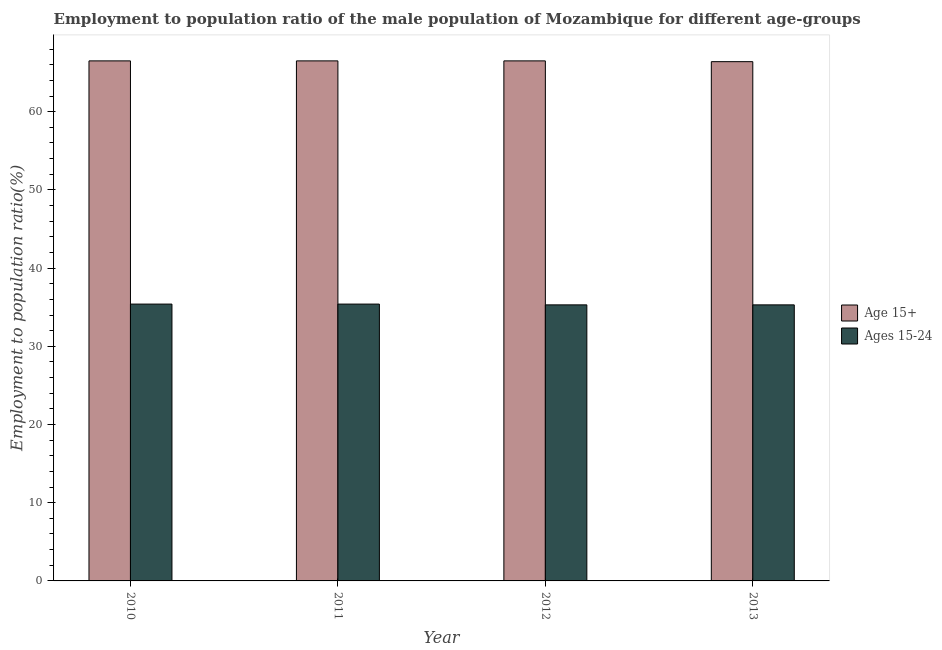How many different coloured bars are there?
Ensure brevity in your answer.  2. How many groups of bars are there?
Give a very brief answer. 4. Are the number of bars on each tick of the X-axis equal?
Give a very brief answer. Yes. How many bars are there on the 1st tick from the left?
Ensure brevity in your answer.  2. How many bars are there on the 1st tick from the right?
Ensure brevity in your answer.  2. What is the label of the 1st group of bars from the left?
Provide a short and direct response. 2010. What is the employment to population ratio(age 15-24) in 2013?
Your response must be concise. 35.3. Across all years, what is the maximum employment to population ratio(age 15+)?
Give a very brief answer. 66.5. Across all years, what is the minimum employment to population ratio(age 15-24)?
Provide a succinct answer. 35.3. In which year was the employment to population ratio(age 15+) maximum?
Offer a terse response. 2010. What is the total employment to population ratio(age 15-24) in the graph?
Provide a short and direct response. 141.4. What is the difference between the employment to population ratio(age 15-24) in 2010 and that in 2011?
Your answer should be very brief. 0. What is the difference between the employment to population ratio(age 15-24) in 2011 and the employment to population ratio(age 15+) in 2013?
Provide a short and direct response. 0.1. What is the average employment to population ratio(age 15+) per year?
Your response must be concise. 66.48. In the year 2013, what is the difference between the employment to population ratio(age 15-24) and employment to population ratio(age 15+)?
Your response must be concise. 0. In how many years, is the employment to population ratio(age 15-24) greater than 42 %?
Give a very brief answer. 0. What is the ratio of the employment to population ratio(age 15+) in 2010 to that in 2013?
Ensure brevity in your answer.  1. What is the difference between the highest and the lowest employment to population ratio(age 15+)?
Your answer should be compact. 0.1. In how many years, is the employment to population ratio(age 15+) greater than the average employment to population ratio(age 15+) taken over all years?
Provide a succinct answer. 3. What does the 1st bar from the left in 2010 represents?
Offer a terse response. Age 15+. What does the 2nd bar from the right in 2013 represents?
Offer a terse response. Age 15+. How many bars are there?
Your answer should be very brief. 8. What is the difference between two consecutive major ticks on the Y-axis?
Ensure brevity in your answer.  10. Are the values on the major ticks of Y-axis written in scientific E-notation?
Make the answer very short. No. How many legend labels are there?
Your response must be concise. 2. What is the title of the graph?
Provide a succinct answer. Employment to population ratio of the male population of Mozambique for different age-groups. What is the label or title of the Y-axis?
Offer a very short reply. Employment to population ratio(%). What is the Employment to population ratio(%) in Age 15+ in 2010?
Provide a short and direct response. 66.5. What is the Employment to population ratio(%) of Ages 15-24 in 2010?
Ensure brevity in your answer.  35.4. What is the Employment to population ratio(%) in Age 15+ in 2011?
Keep it short and to the point. 66.5. What is the Employment to population ratio(%) of Ages 15-24 in 2011?
Keep it short and to the point. 35.4. What is the Employment to population ratio(%) of Age 15+ in 2012?
Keep it short and to the point. 66.5. What is the Employment to population ratio(%) of Ages 15-24 in 2012?
Keep it short and to the point. 35.3. What is the Employment to population ratio(%) of Age 15+ in 2013?
Keep it short and to the point. 66.4. What is the Employment to population ratio(%) of Ages 15-24 in 2013?
Offer a very short reply. 35.3. Across all years, what is the maximum Employment to population ratio(%) of Age 15+?
Give a very brief answer. 66.5. Across all years, what is the maximum Employment to population ratio(%) in Ages 15-24?
Your response must be concise. 35.4. Across all years, what is the minimum Employment to population ratio(%) of Age 15+?
Offer a very short reply. 66.4. Across all years, what is the minimum Employment to population ratio(%) in Ages 15-24?
Make the answer very short. 35.3. What is the total Employment to population ratio(%) of Age 15+ in the graph?
Your answer should be very brief. 265.9. What is the total Employment to population ratio(%) of Ages 15-24 in the graph?
Your response must be concise. 141.4. What is the difference between the Employment to population ratio(%) in Age 15+ in 2010 and that in 2011?
Provide a short and direct response. 0. What is the difference between the Employment to population ratio(%) in Ages 15-24 in 2010 and that in 2011?
Your response must be concise. 0. What is the difference between the Employment to population ratio(%) of Ages 15-24 in 2010 and that in 2012?
Your answer should be compact. 0.1. What is the difference between the Employment to population ratio(%) of Age 15+ in 2012 and that in 2013?
Give a very brief answer. 0.1. What is the difference between the Employment to population ratio(%) in Ages 15-24 in 2012 and that in 2013?
Your answer should be compact. 0. What is the difference between the Employment to population ratio(%) of Age 15+ in 2010 and the Employment to population ratio(%) of Ages 15-24 in 2011?
Make the answer very short. 31.1. What is the difference between the Employment to population ratio(%) of Age 15+ in 2010 and the Employment to population ratio(%) of Ages 15-24 in 2012?
Your answer should be compact. 31.2. What is the difference between the Employment to population ratio(%) of Age 15+ in 2010 and the Employment to population ratio(%) of Ages 15-24 in 2013?
Offer a terse response. 31.2. What is the difference between the Employment to population ratio(%) in Age 15+ in 2011 and the Employment to population ratio(%) in Ages 15-24 in 2012?
Provide a succinct answer. 31.2. What is the difference between the Employment to population ratio(%) in Age 15+ in 2011 and the Employment to population ratio(%) in Ages 15-24 in 2013?
Your response must be concise. 31.2. What is the difference between the Employment to population ratio(%) in Age 15+ in 2012 and the Employment to population ratio(%) in Ages 15-24 in 2013?
Offer a terse response. 31.2. What is the average Employment to population ratio(%) in Age 15+ per year?
Offer a terse response. 66.47. What is the average Employment to population ratio(%) of Ages 15-24 per year?
Your answer should be very brief. 35.35. In the year 2010, what is the difference between the Employment to population ratio(%) of Age 15+ and Employment to population ratio(%) of Ages 15-24?
Offer a terse response. 31.1. In the year 2011, what is the difference between the Employment to population ratio(%) of Age 15+ and Employment to population ratio(%) of Ages 15-24?
Make the answer very short. 31.1. In the year 2012, what is the difference between the Employment to population ratio(%) of Age 15+ and Employment to population ratio(%) of Ages 15-24?
Offer a terse response. 31.2. In the year 2013, what is the difference between the Employment to population ratio(%) in Age 15+ and Employment to population ratio(%) in Ages 15-24?
Provide a short and direct response. 31.1. What is the ratio of the Employment to population ratio(%) of Age 15+ in 2010 to that in 2011?
Offer a terse response. 1. What is the ratio of the Employment to population ratio(%) of Ages 15-24 in 2010 to that in 2011?
Provide a succinct answer. 1. What is the ratio of the Employment to population ratio(%) of Ages 15-24 in 2010 to that in 2012?
Make the answer very short. 1. What is the ratio of the Employment to population ratio(%) in Age 15+ in 2011 to that in 2012?
Your answer should be very brief. 1. What is the ratio of the Employment to population ratio(%) in Ages 15-24 in 2011 to that in 2012?
Offer a very short reply. 1. What is the ratio of the Employment to population ratio(%) in Ages 15-24 in 2011 to that in 2013?
Provide a short and direct response. 1. What is the difference between the highest and the second highest Employment to population ratio(%) of Age 15+?
Your response must be concise. 0. What is the difference between the highest and the second highest Employment to population ratio(%) in Ages 15-24?
Provide a succinct answer. 0. What is the difference between the highest and the lowest Employment to population ratio(%) in Age 15+?
Ensure brevity in your answer.  0.1. What is the difference between the highest and the lowest Employment to population ratio(%) in Ages 15-24?
Keep it short and to the point. 0.1. 